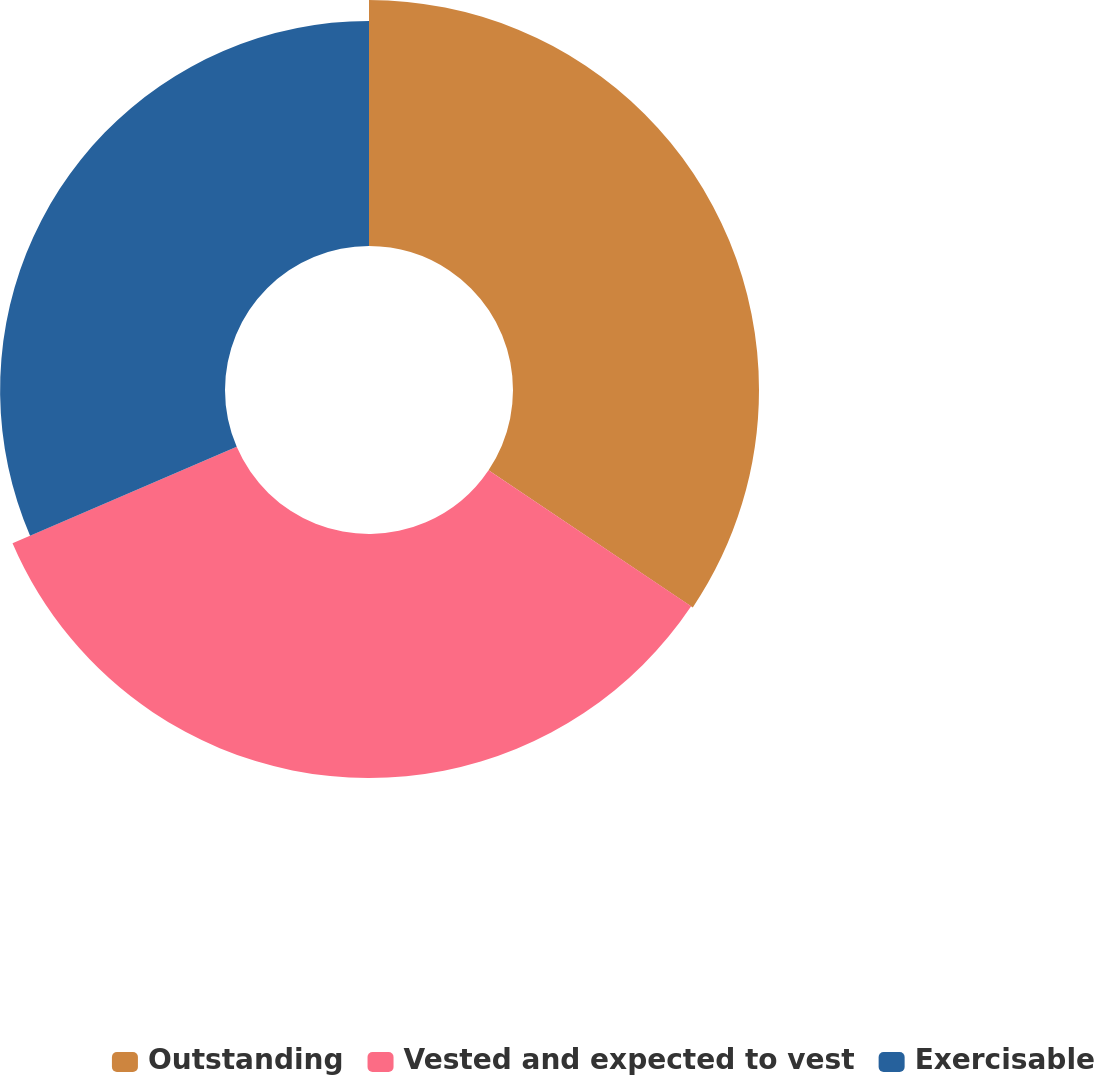Convert chart to OTSL. <chart><loc_0><loc_0><loc_500><loc_500><pie_chart><fcel>Outstanding<fcel>Vested and expected to vest<fcel>Exercisable<nl><fcel>34.41%<fcel>34.13%<fcel>31.46%<nl></chart> 